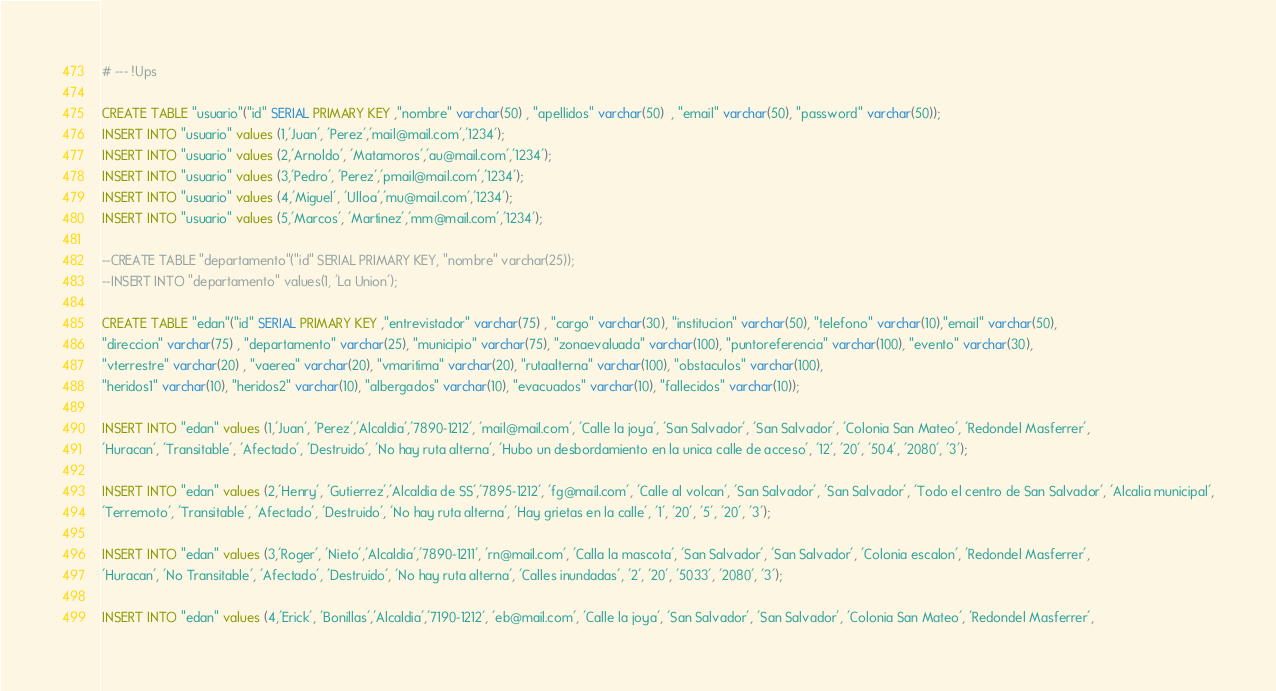Convert code to text. <code><loc_0><loc_0><loc_500><loc_500><_SQL_># --- !Ups

CREATE TABLE "usuario"("id" SERIAL PRIMARY KEY ,"nombre" varchar(50) , "apellidos" varchar(50)  , "email" varchar(50), "password" varchar(50));
INSERT INTO "usuario" values (1,'Juan', 'Perez','mail@mail.com','1234');
INSERT INTO "usuario" values (2,'Arnoldo', 'Matamoros','au@mail.com','1234');
INSERT INTO "usuario" values (3,'Pedro', 'Perez','pmail@mail.com','1234');
INSERT INTO "usuario" values (4,'Miguel', 'Ulloa','mu@mail.com','1234');
INSERT INTO "usuario" values (5,'Marcos', 'Martinez','mm@mail.com','1234');

--CREATE TABLE "departamento"("id" SERIAL PRIMARY KEY, "nombre" varchar(25));
--INSERT INTO "departamento" values(1, 'La Union');

CREATE TABLE "edan"("id" SERIAL PRIMARY KEY ,"entrevistador" varchar(75) , "cargo" varchar(30), "institucion" varchar(50), "telefono" varchar(10),"email" varchar(50),
"direccion" varchar(75) , "departamento" varchar(25), "municipio" varchar(75), "zonaevaluada" varchar(100), "puntoreferencia" varchar(100), "evento" varchar(30),
"vterrestre" varchar(20) , "vaerea" varchar(20), "vmaritima" varchar(20), "rutaalterna" varchar(100), "obstaculos" varchar(100),
"heridos1" varchar(10), "heridos2" varchar(10), "albergados" varchar(10), "evacuados" varchar(10), "fallecidos" varchar(10));

INSERT INTO "edan" values (1,'Juan', 'Perez','Alcaldia','7890-1212', 'mail@mail.com', 'Calle la joya', 'San Salvador', 'San Salvador', 'Colonia San Mateo', 'Redondel Masferrer',
'Huracan', 'Transitable', 'Afectado', 'Destruido', 'No hay ruta alterna', 'Hubo un desbordamiento en la unica calle de acceso', '12', '20', '504', '2080', '3');

INSERT INTO "edan" values (2,'Henry', 'Gutierrez','Alcaldia de SS','7895-1212', 'fg@mail.com', 'Calle al volcan', 'San Salvador', 'San Salvador', 'Todo el centro de San Salvador', 'Alcalia municipal',
'Terremoto', 'Transitable', 'Afectado', 'Destruido', 'No hay ruta alterna', 'Hay grietas en la calle', '1', '20', '5', '20', '3');

INSERT INTO "edan" values (3,'Roger', 'Nieto','Alcaldia','7890-1211', 'rn@mail.com', 'Calla la mascota', 'San Salvador', 'San Salvador', 'Colonia escalon', 'Redondel Masferrer',
'Huracan', 'No Transitable', 'Afectado', 'Destruido', 'No hay ruta alterna', 'Calles inundadas', '2', '20', '5033', '2080', '3');

INSERT INTO "edan" values (4,'Erick', 'Bonillas','Alcaldia','7190-1212', 'eb@mail.com', 'Calle la joya', 'San Salvador', 'San Salvador', 'Colonia San Mateo', 'Redondel Masferrer',</code> 